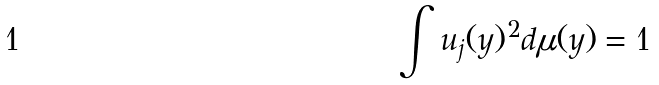<formula> <loc_0><loc_0><loc_500><loc_500>\int u _ { j } ( y ) ^ { 2 } d \mu ( y ) = 1</formula> 